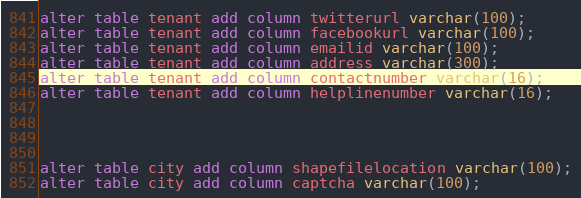Convert code to text. <code><loc_0><loc_0><loc_500><loc_500><_SQL_>alter table tenant add column twitterurl varchar(100);
alter table tenant add column facebookurl varchar(100);
alter table tenant add column emailid varchar(100);
alter table tenant add column address varchar(300);
alter table tenant add column contactnumber varchar(16);
alter table tenant add column helplinenumber varchar(16);




alter table city add column shapefilelocation varchar(100);
alter table city add column captcha varchar(100); 


</code> 